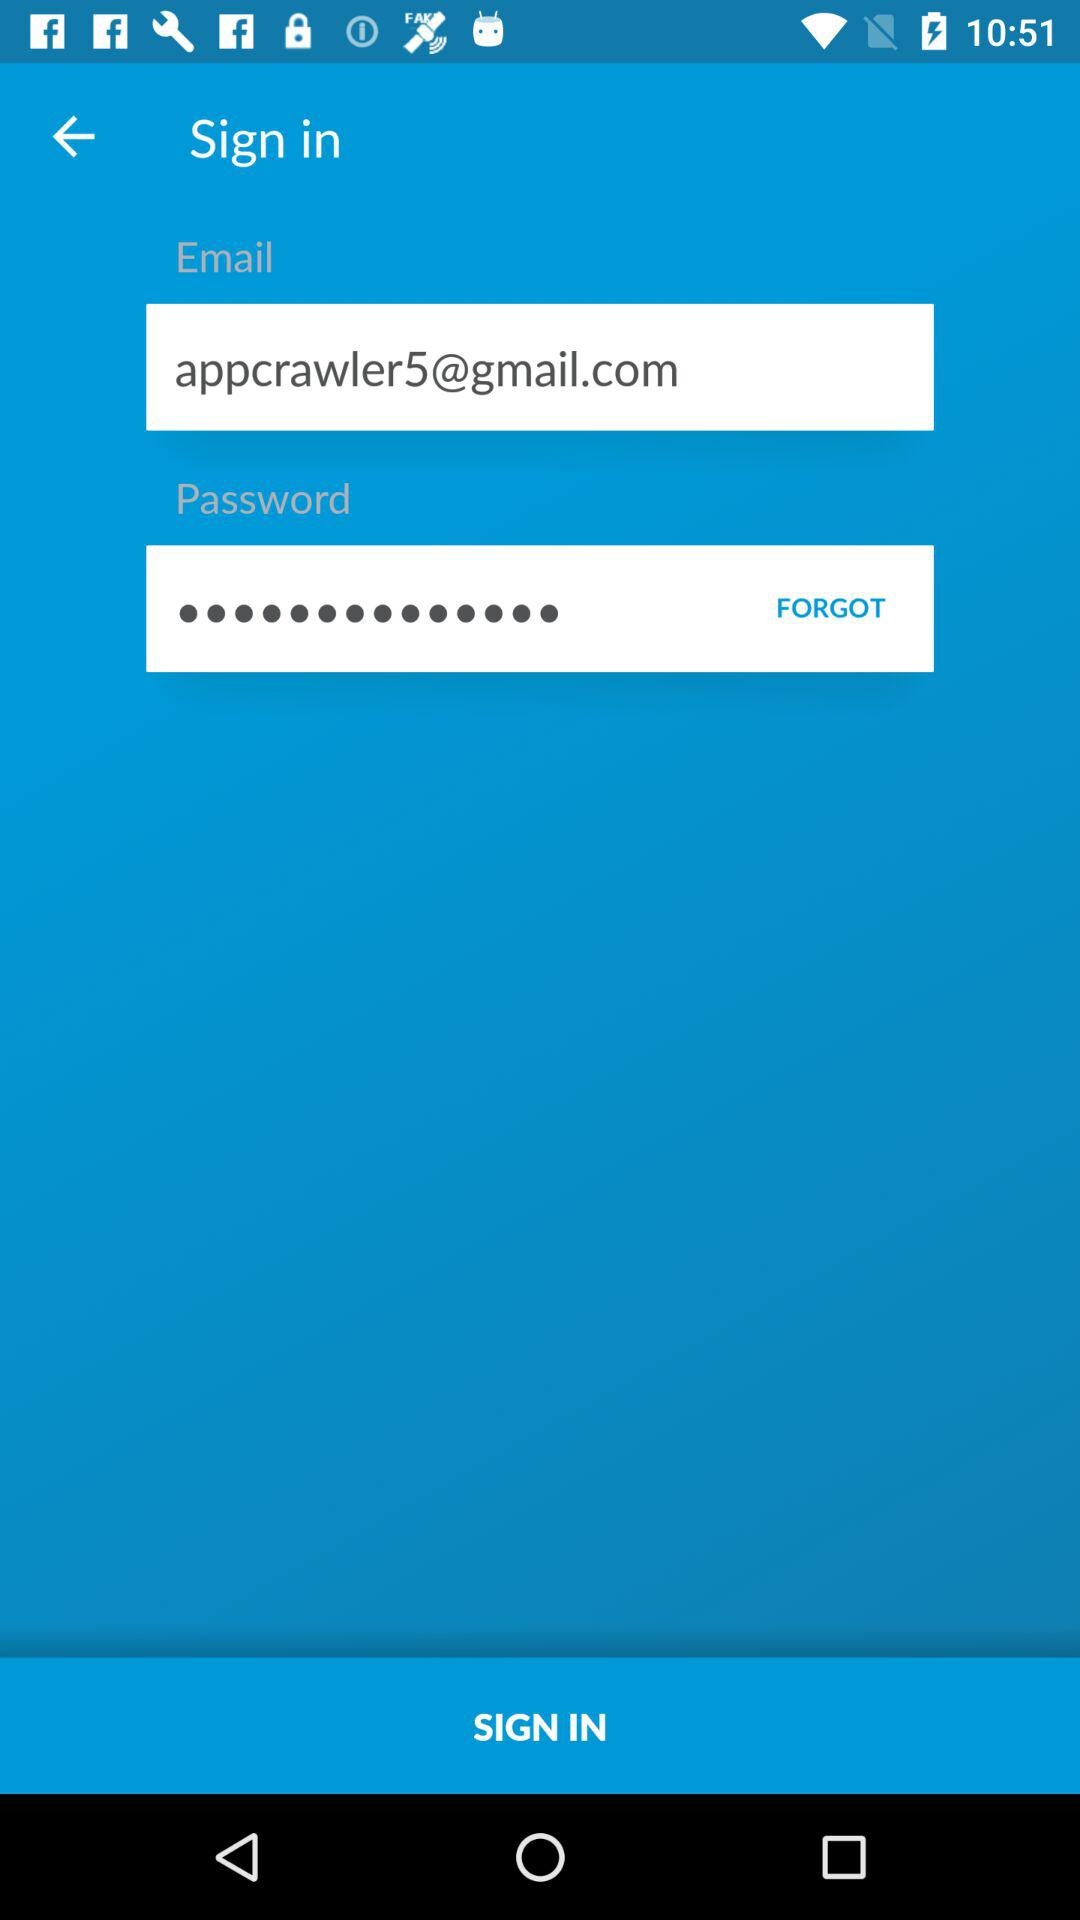What is the email address? The email address is appcrawler5@gmail.com. 